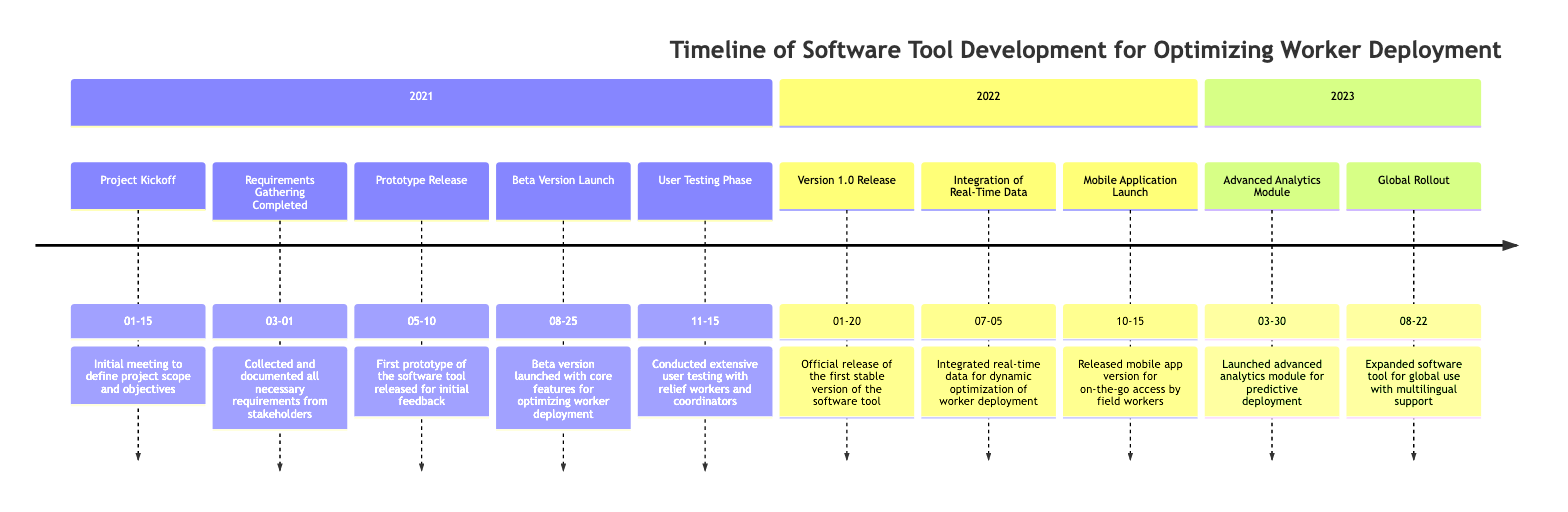What was the date of the Prototype Release? The timeline states that the Prototype Release event occurred on May 10, 2021. This can be found by locating the specific milestone on the timeline that corresponds to the Prototype Release, which lists the date alongside the event.
Answer: May 10, 2021 How many key releases are there in 2022? To determine the number of key releases in 2022, we examine the timeline section for that year. It lists three events: Version 1.0 Release, Integration of Real-Time Data, and Mobile Application Launch. Therefore, there are three key releases documented for 2022.
Answer: 3 What event occurred just before the Global Rollout? The event that preceded the Global Rollout, which occurred on August 22, 2023, is the Advanced Analytics Module, launched on March 30, 2023. By analyzing the timeline's chronological order, we identify that March 30 is the direct event that comes before August 22.
Answer: Advanced Analytics Module Which event included user testing? The event entitled "User Testing Phase," which took place on November 15, 2021, specifically describes user testing being conducted with relief workers and coordinators. This can be confirmed by finding the associated description with that event in the timeline.
Answer: User Testing Phase What month was the Mobile Application Launch? The Mobile Application Launch occurred in October 2022, as indicated in the timeline. By locating the Mobile Application Launch event and observing its associated date, we confirm the month of October.
Answer: October 2022 How much time elapsed between the Beta Version Launch and Version 1.0 Release? The Beta Version Launch occurred on August 25, 2021, and the Version 1.0 Release took place on January 20, 2022. To determine the elapsed time, we calculate the duration between these two dates, which is approximately 4.5 months.
Answer: Approximately 4.5 months What feature was added on July 5, 2022? On July 5, 2022, the feature added was the Integration of Real-Time Data, which is noted in the timeline. By locating that specific date, we can also reference the event to see the new feature being discussed.
Answer: Integration of Real-Time Data How many events are listed in 2021? The timeline lists five events for the year 2021: Project Kickoff, Requirements Gathering Completed, Prototype Release, Beta Version Launch, and User Testing Phase. Counting each of these events confirms the total.
Answer: 5 